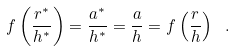Convert formula to latex. <formula><loc_0><loc_0><loc_500><loc_500>f \left ( \frac { r ^ { * } } { h ^ { * } } \right ) = \frac { a ^ { * } } { h ^ { * } } = \frac { a } { h } = f \left ( \frac { r } { h } \right ) \ .</formula> 